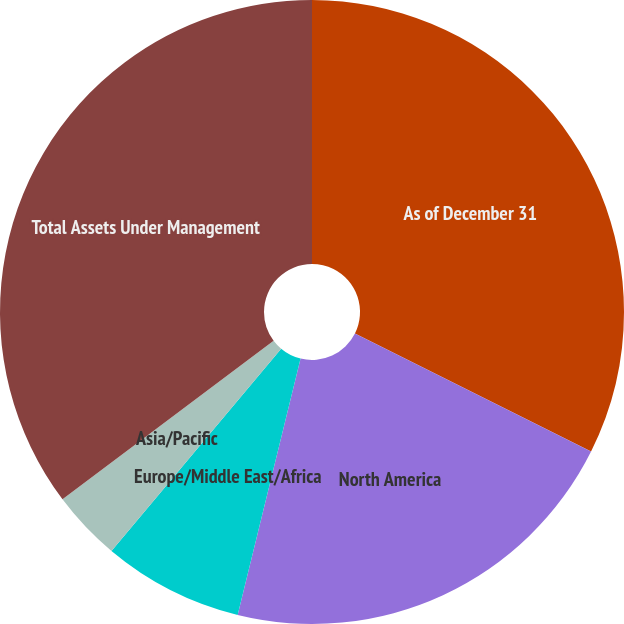Convert chart. <chart><loc_0><loc_0><loc_500><loc_500><pie_chart><fcel>As of December 31<fcel>North America<fcel>Europe/Middle East/Africa<fcel>Asia/Pacific<fcel>Total Assets Under Management<nl><fcel>32.38%<fcel>21.45%<fcel>7.28%<fcel>3.64%<fcel>35.25%<nl></chart> 